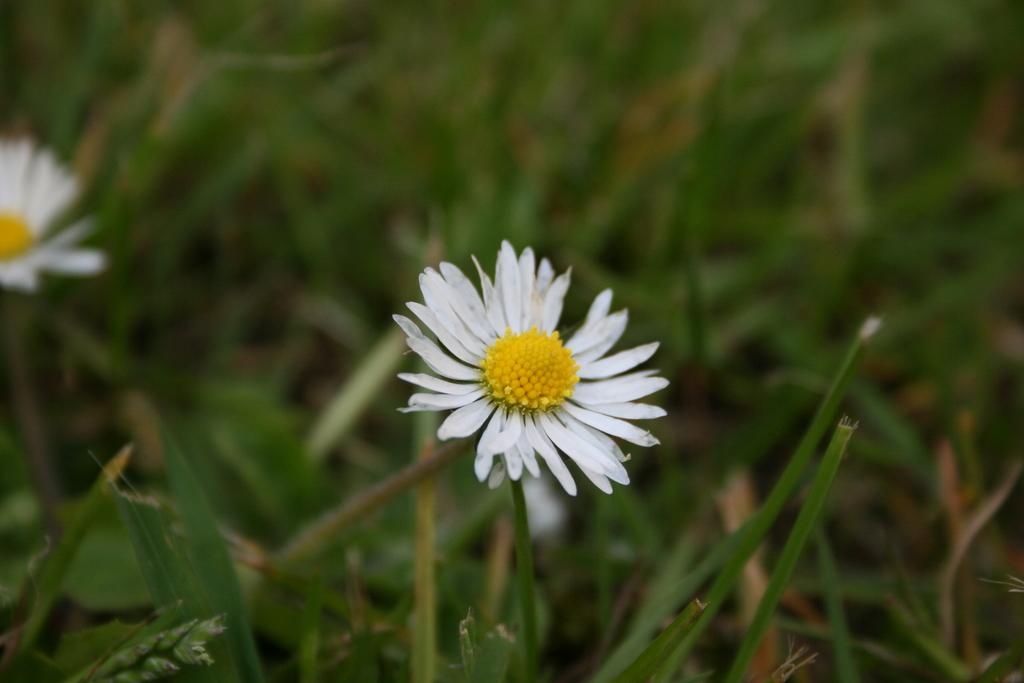What type of living organisms can be seen in the image? Plants and flowers are visible in the image. Can you describe the flowers in the image? The flowers in the image are part of the plants and add color and beauty to the scene. What type of dinner is being served in the image? There is no dinner present in the image; it features plants and flowers. How much debt is visible in the image? There is no mention of debt in the image; it focuses on plants and flowers. 